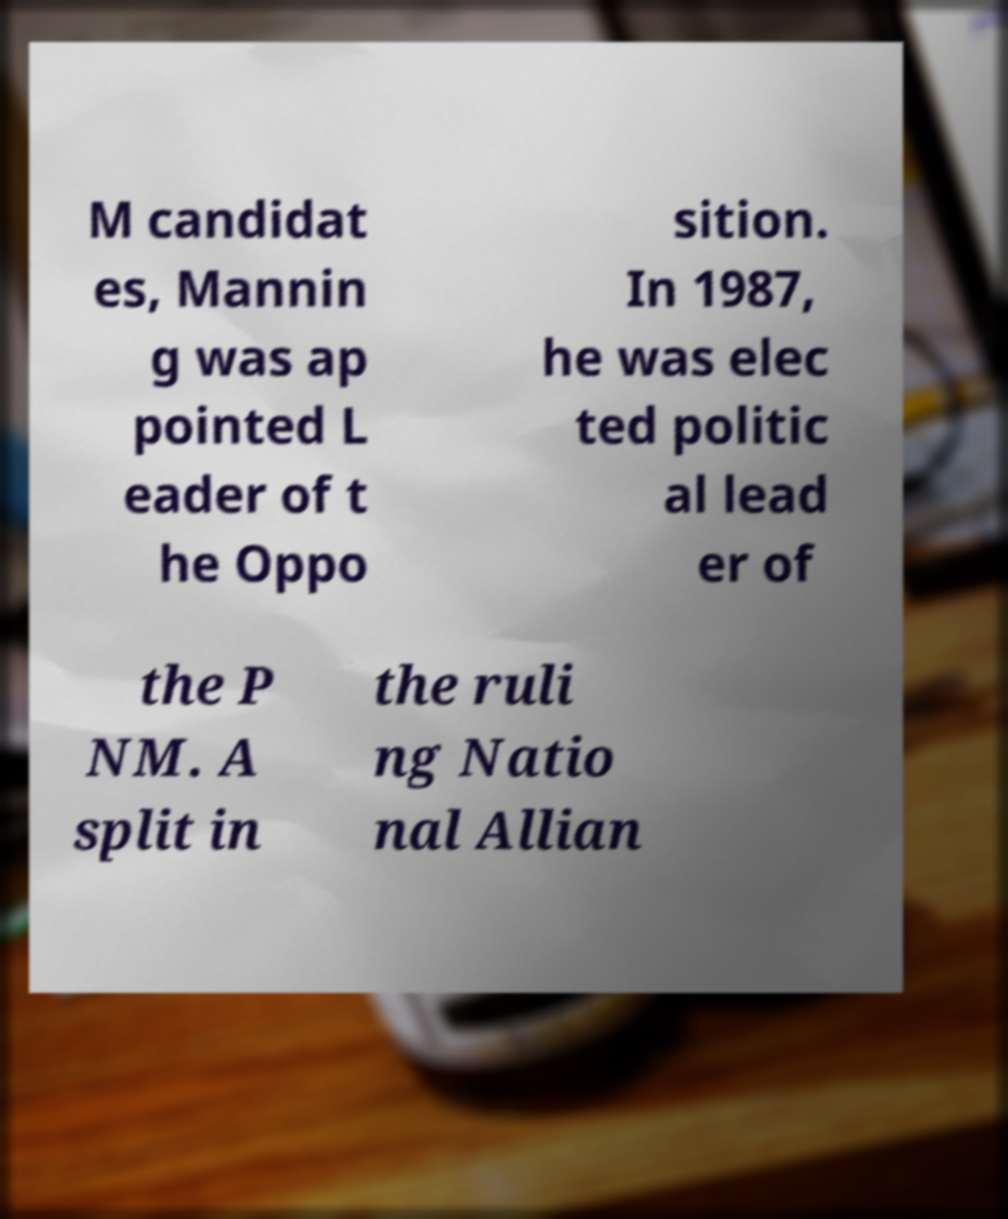Can you accurately transcribe the text from the provided image for me? M candidat es, Mannin g was ap pointed L eader of t he Oppo sition. In 1987, he was elec ted politic al lead er of the P NM. A split in the ruli ng Natio nal Allian 